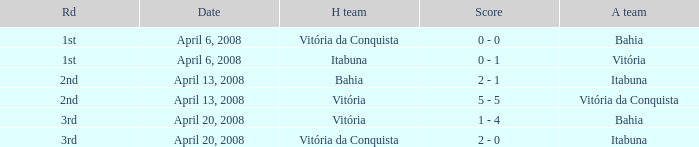What home team has a score of 5 - 5? Vitória. 